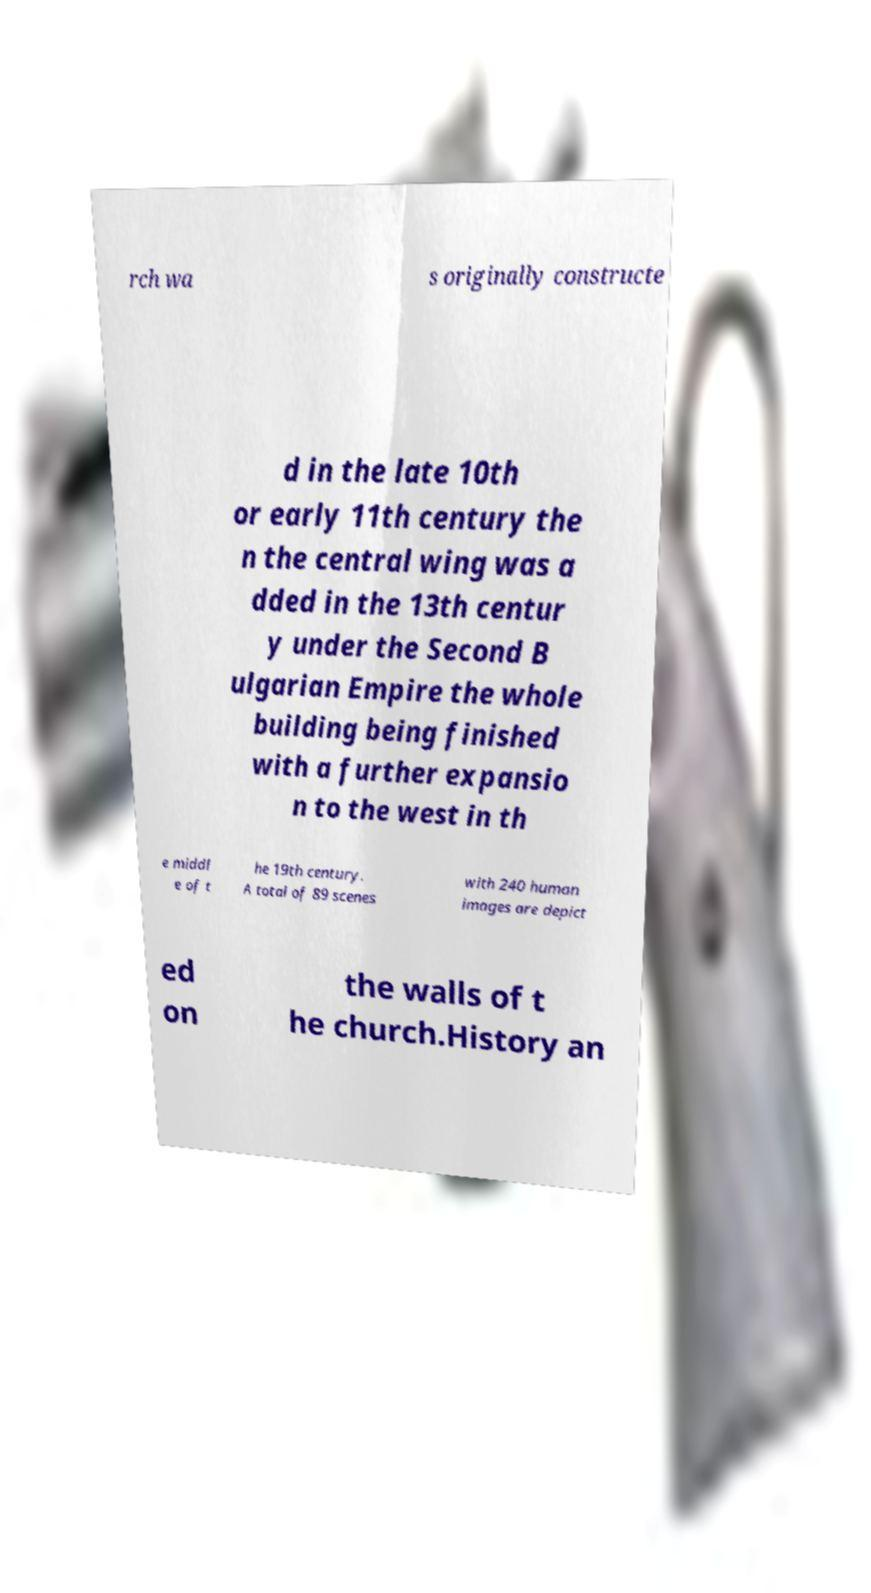Could you extract and type out the text from this image? rch wa s originally constructe d in the late 10th or early 11th century the n the central wing was a dded in the 13th centur y under the Second B ulgarian Empire the whole building being finished with a further expansio n to the west in th e middl e of t he 19th century. A total of 89 scenes with 240 human images are depict ed on the walls of t he church.History an 